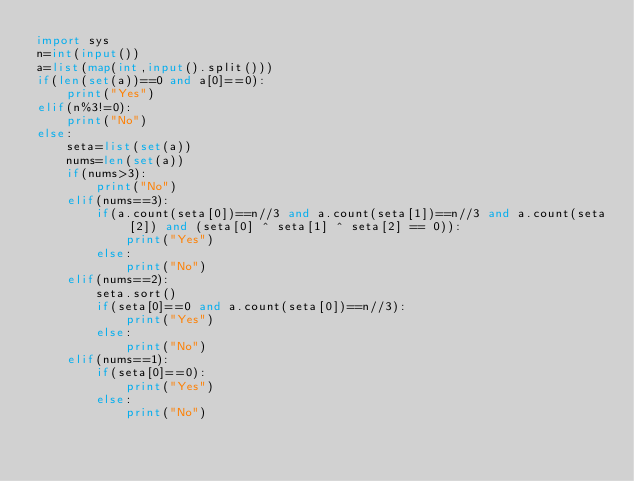Convert code to text. <code><loc_0><loc_0><loc_500><loc_500><_Python_>import sys
n=int(input())
a=list(map(int,input().split()))
if(len(set(a))==0 and a[0]==0):
    print("Yes")
elif(n%3!=0):
    print("No")
else:
    seta=list(set(a))
    nums=len(set(a))
    if(nums>3):
        print("No")
    elif(nums==3):
        if(a.count(seta[0])==n//3 and a.count(seta[1])==n//3 and a.count(seta[2]) and (seta[0] ^ seta[1] ^ seta[2] == 0)):
            print("Yes")
        else:
            print("No")
    elif(nums==2):
        seta.sort()
        if(seta[0]==0 and a.count(seta[0])==n//3):
            print("Yes")
        else:
            print("No")
    elif(nums==1):
        if(seta[0]==0):
            print("Yes")
        else:
            print("No")
</code> 